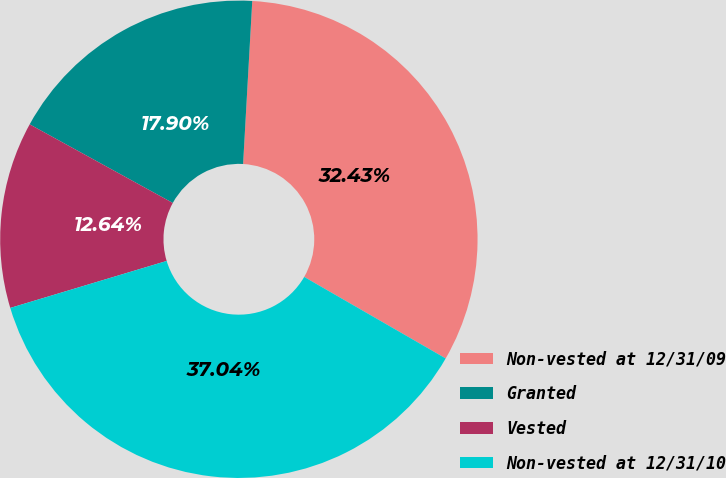<chart> <loc_0><loc_0><loc_500><loc_500><pie_chart><fcel>Non-vested at 12/31/09<fcel>Granted<fcel>Vested<fcel>Non-vested at 12/31/10<nl><fcel>32.43%<fcel>17.9%<fcel>12.64%<fcel>37.04%<nl></chart> 